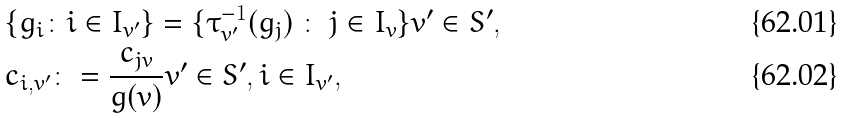Convert formula to latex. <formula><loc_0><loc_0><loc_500><loc_500>& \{ g _ { i } \colon i \in I _ { v ^ { \prime } } \} = \{ \tau ^ { - 1 } _ { v ^ { \prime } } ( g _ { j } ) \ \colon \ j \in I _ { v } \} v ^ { \prime } \in S ^ { \prime } , \\ & c _ { i , v ^ { \prime } } \colon = \frac { c _ { j v } } { g ( v ) } v ^ { \prime } \in S ^ { \prime } , i \in I _ { v ^ { \prime } } ,</formula> 